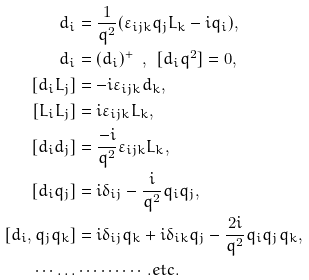<formula> <loc_0><loc_0><loc_500><loc_500>d _ { i } & = \frac { 1 } { q ^ { 2 } } ( \varepsilon _ { i j k } q _ { j } L _ { k } - i q _ { i } ) , \\ d _ { i } & = ( d _ { i } ) ^ { + } \ \ , \ \ [ d _ { i } q ^ { 2 } ] = 0 , \\ [ d _ { i } L _ { j } ] & = - i \varepsilon _ { i j k } d _ { k } , \\ [ L _ { i } L _ { j } ] & = i \varepsilon _ { i j k } L _ { k } , \\ [ d _ { i } d _ { j } ] & = \frac { - i } { q ^ { 2 } } \varepsilon _ { i j k } L _ { k } , \\ [ d _ { i } q _ { j } ] & = i \delta _ { i j } - \frac { i } { q ^ { 2 } } q _ { i } q _ { j } , \\ [ d _ { i } , q _ { j } q _ { k } ] & = i \delta _ { i j } q _ { k } + i \delta _ { i k } q _ { j } - \frac { 2 i } { q ^ { 2 } } q _ { i } q _ { j } q _ { k } , \\ \cdots \dots & \cdots \cdots \cdots . e t c .</formula> 